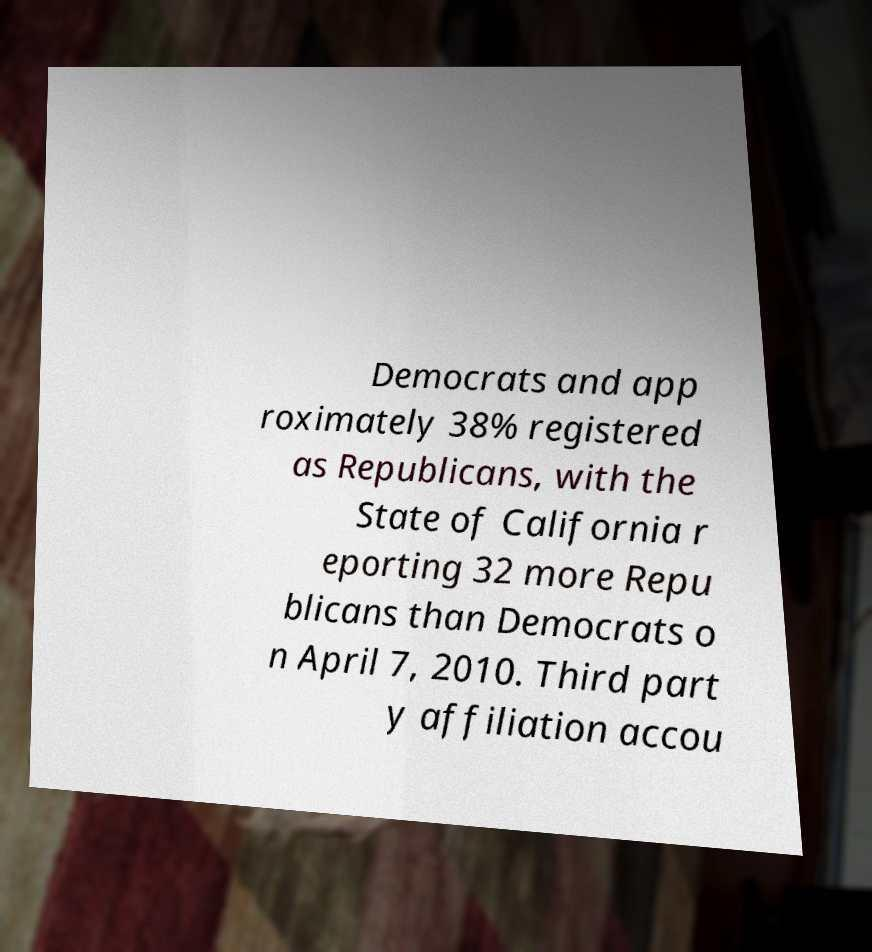Could you extract and type out the text from this image? Democrats and app roximately 38% registered as Republicans, with the State of California r eporting 32 more Repu blicans than Democrats o n April 7, 2010. Third part y affiliation accou 